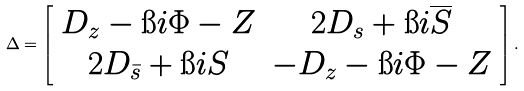<formula> <loc_0><loc_0><loc_500><loc_500>\Delta = \left [ \begin{array} { c c } D _ { z } - \i i \Phi - Z & 2 D _ { s } + \i i \overline { S } \\ 2 D _ { \bar { s } } + \i i S & - D _ { z } - \i i \Phi - Z \end{array} \right ] .</formula> 